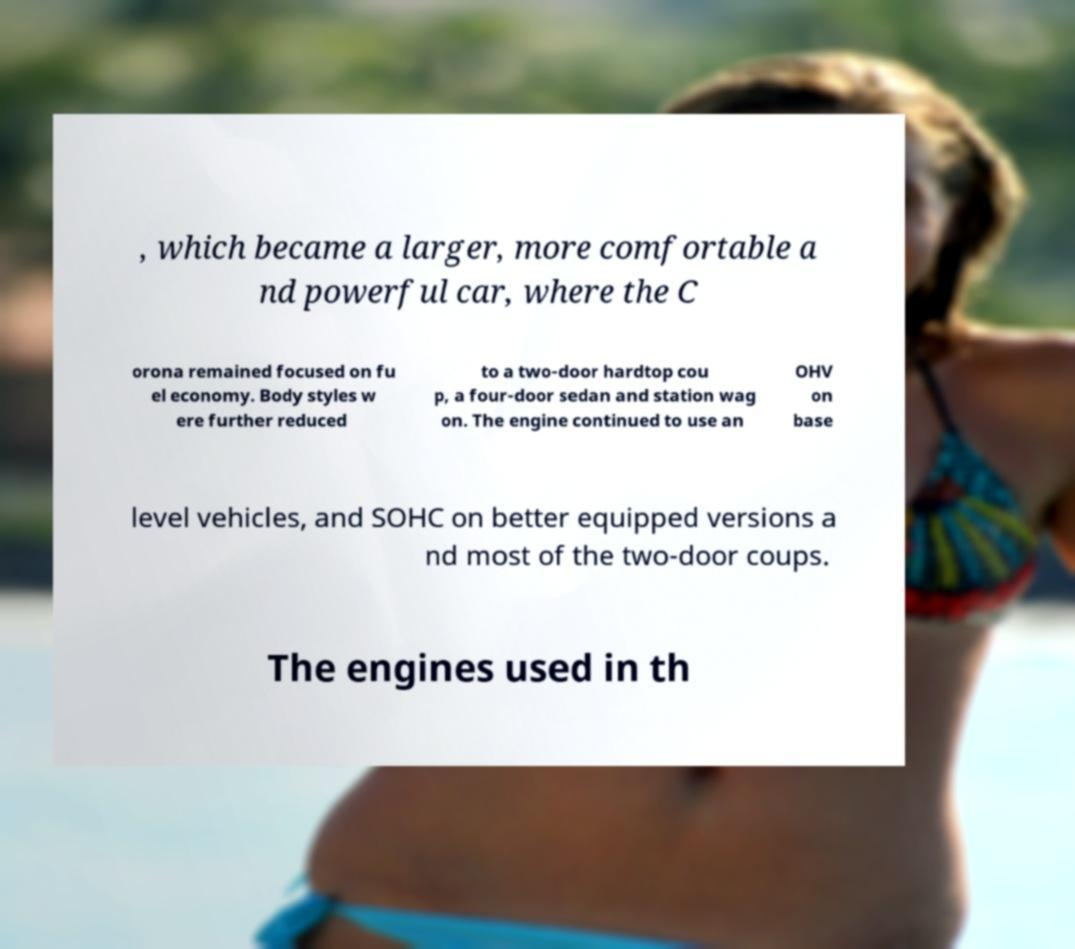There's text embedded in this image that I need extracted. Can you transcribe it verbatim? , which became a larger, more comfortable a nd powerful car, where the C orona remained focused on fu el economy. Body styles w ere further reduced to a two-door hardtop cou p, a four-door sedan and station wag on. The engine continued to use an OHV on base level vehicles, and SOHC on better equipped versions a nd most of the two-door coups. The engines used in th 